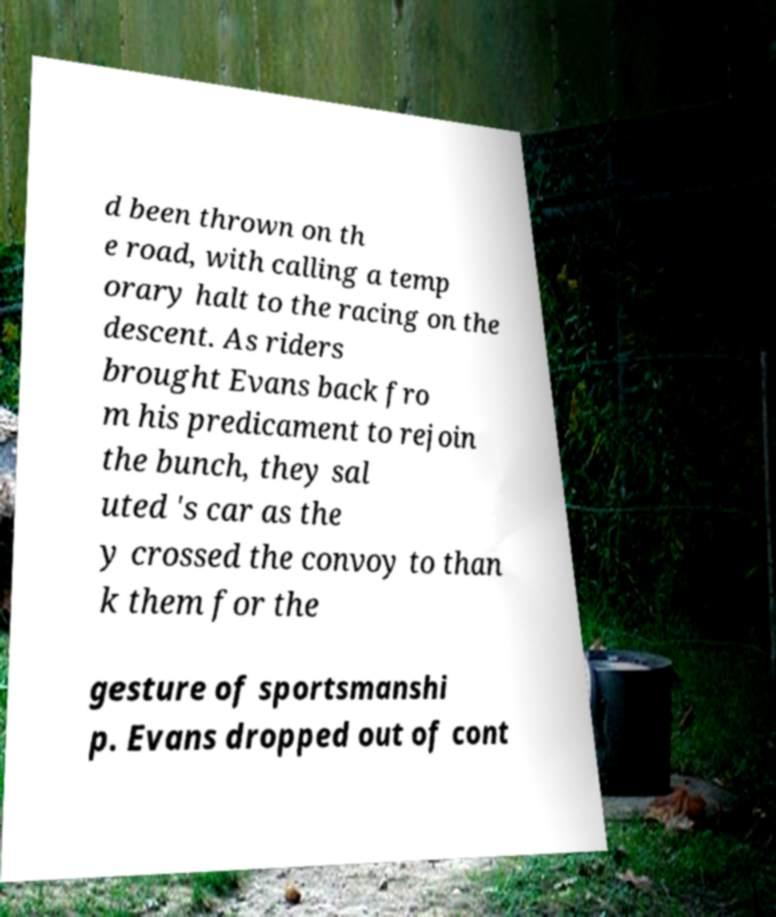There's text embedded in this image that I need extracted. Can you transcribe it verbatim? d been thrown on th e road, with calling a temp orary halt to the racing on the descent. As riders brought Evans back fro m his predicament to rejoin the bunch, they sal uted 's car as the y crossed the convoy to than k them for the gesture of sportsmanshi p. Evans dropped out of cont 